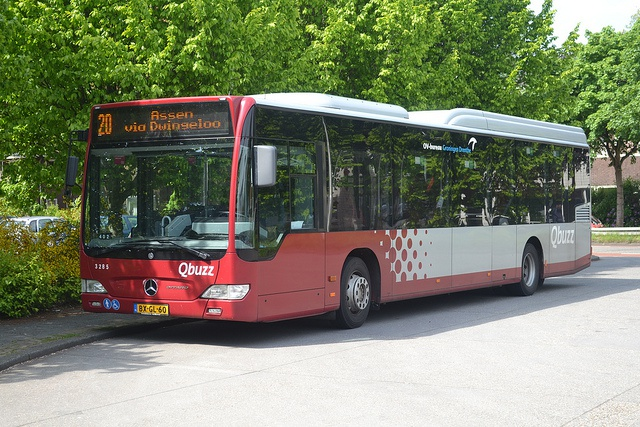Describe the objects in this image and their specific colors. I can see bus in darkgreen, black, gray, brown, and darkgray tones, car in darkgreen, olive, gray, darkgray, and lightgray tones, and car in darkgreen, gray, lightpink, darkgray, and black tones in this image. 